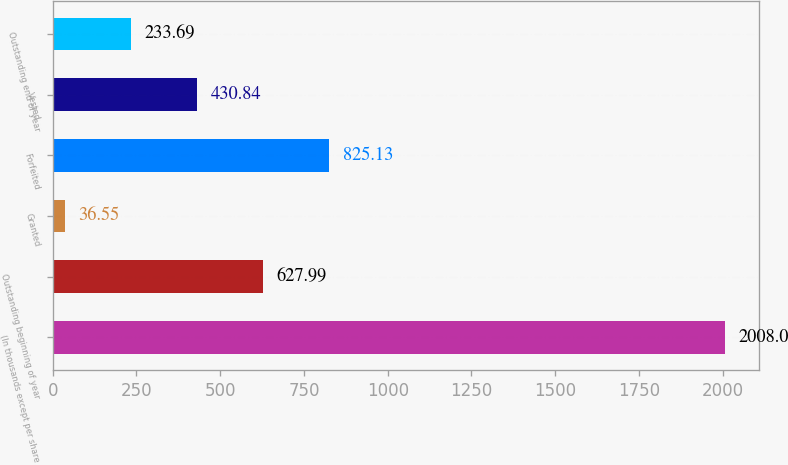Convert chart. <chart><loc_0><loc_0><loc_500><loc_500><bar_chart><fcel>(In thousands except per share<fcel>Outstanding beginning of year<fcel>Granted<fcel>Forfeited<fcel>Vested<fcel>Outstanding end of year<nl><fcel>2008<fcel>627.99<fcel>36.55<fcel>825.13<fcel>430.84<fcel>233.69<nl></chart> 